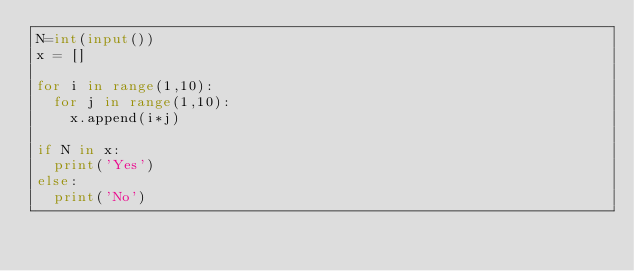Convert code to text. <code><loc_0><loc_0><loc_500><loc_500><_Python_>N=int(input())
x = []

for i in range(1,10):
  for j in range(1,10):
    x.append(i*j)

if N in x:
  print('Yes')
else:
  print('No')
    </code> 